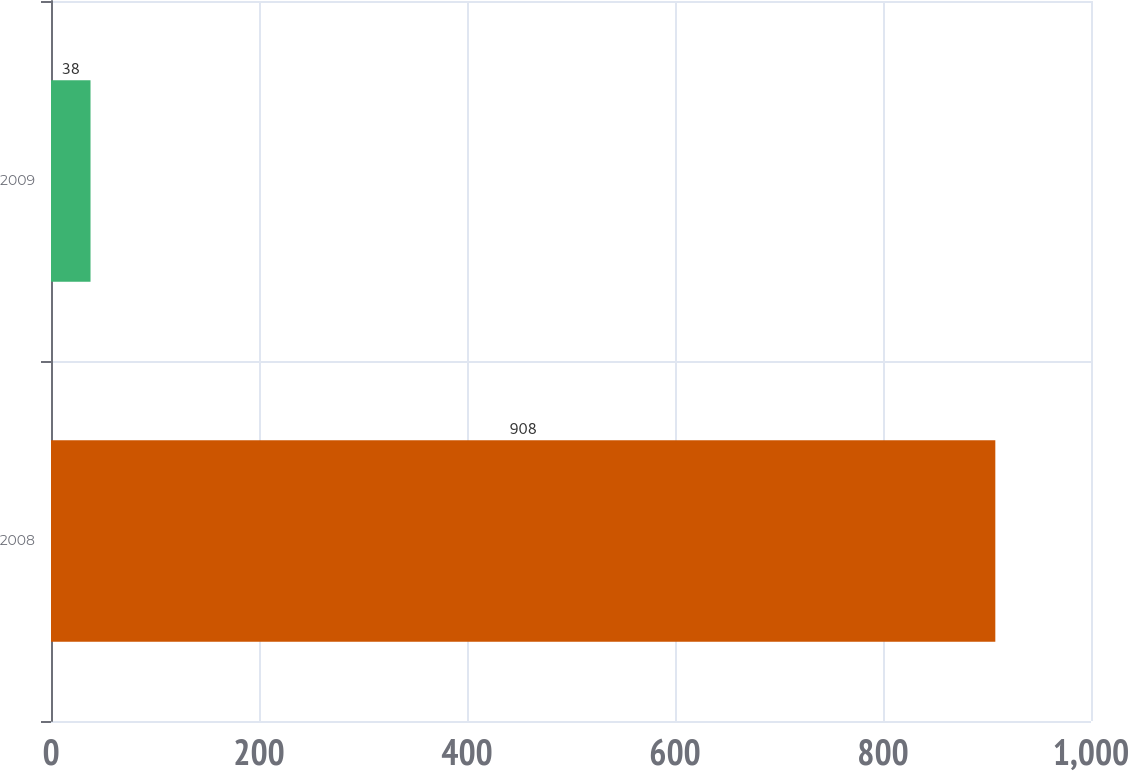Convert chart to OTSL. <chart><loc_0><loc_0><loc_500><loc_500><bar_chart><fcel>2008<fcel>2009<nl><fcel>908<fcel>38<nl></chart> 